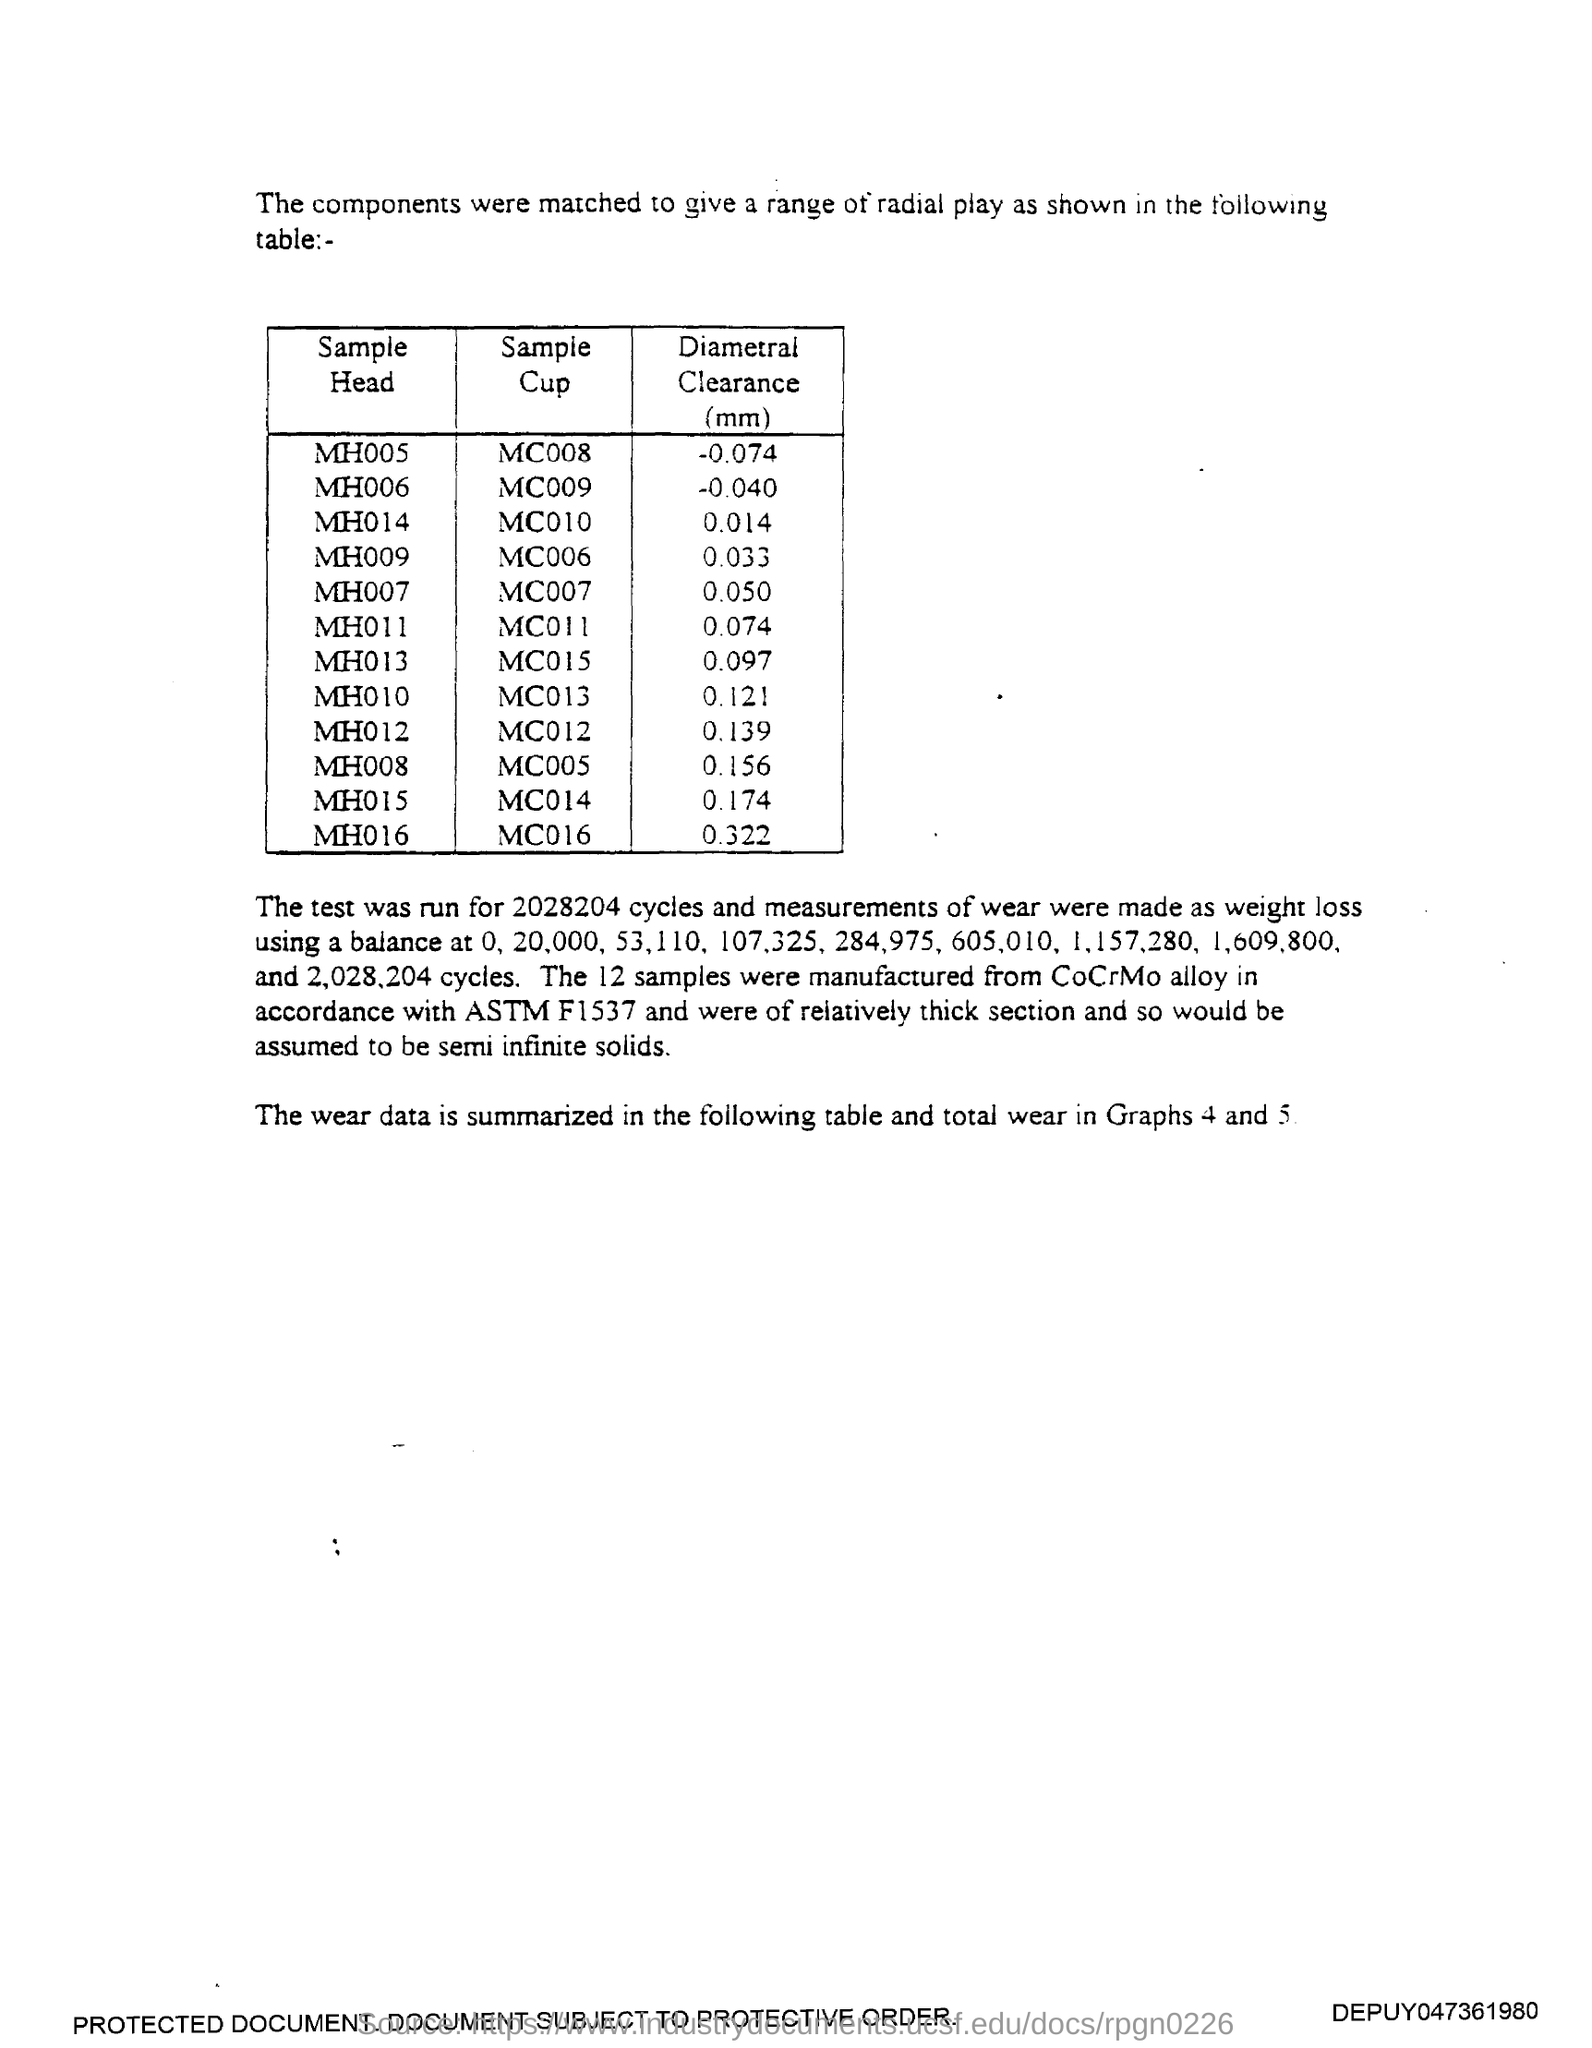List a handful of essential elements in this visual. The diameter clearance for Sample head MH008 is 0.156 millimeters. The diameter clearance for Sample head MH011 is 0.074 millimeters. The diameter clearance for Sample head MH009 is 0.033... The diameter clearance for Sample head MH010 is 0.121 millimeters. The diameter clearance for Sample head MH007 is 0.050 mm. 